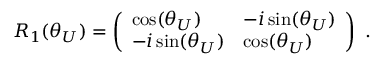<formula> <loc_0><loc_0><loc_500><loc_500>R _ { 1 } ( \theta _ { U } ) = \left ( \begin{array} { l l } { \cos ( \theta _ { U } ) } & { - i \sin ( \theta _ { U } ) } \\ { - i \sin ( \theta _ { U } ) } & { \cos ( \theta _ { U } ) } \end{array} \right ) .</formula> 